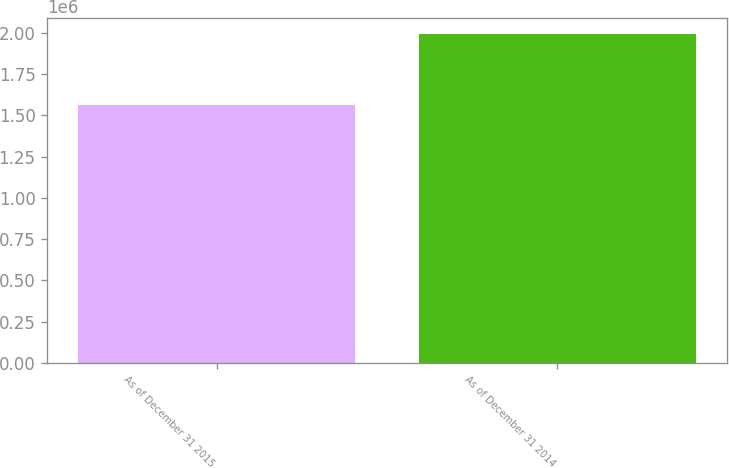Convert chart. <chart><loc_0><loc_0><loc_500><loc_500><bar_chart><fcel>As of December 31 2015<fcel>As of December 31 2014<nl><fcel>1.5645e+06<fcel>1.98957e+06<nl></chart> 